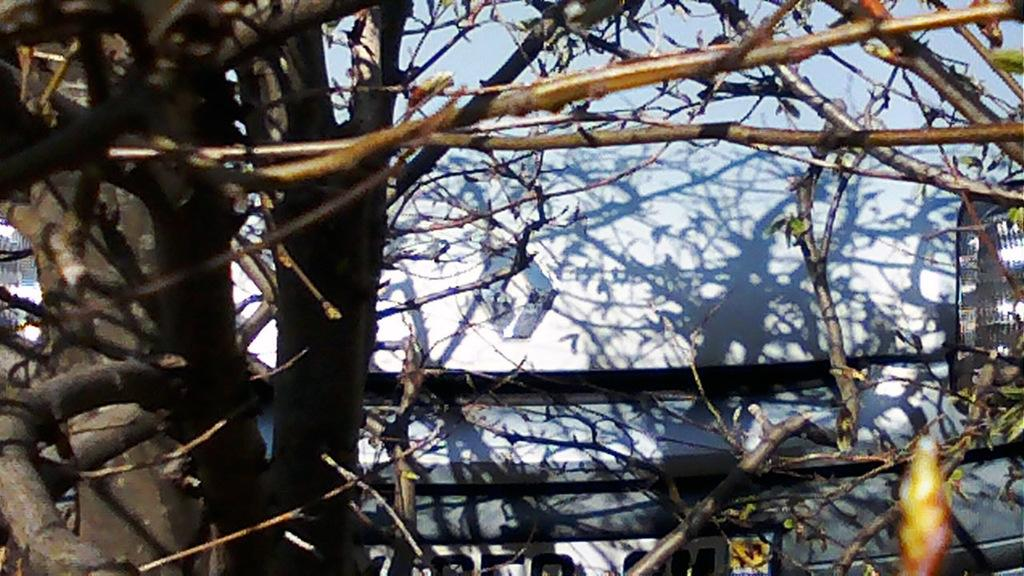What type of plant can be seen in the image? There is a tree without leaves in the image. What else is present in the image besides the tree? There is a wall in the image. How many birds are sitting on the twig in the image? There is no twig or birds present in the image. What type of army can be seen marching in the image? There is no army present in the image. 